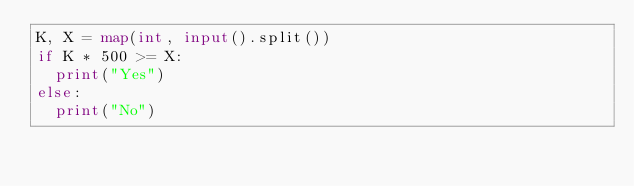<code> <loc_0><loc_0><loc_500><loc_500><_Python_>K, X = map(int, input().split())
if K * 500 >= X:
  print("Yes")
else:
  print("No")</code> 